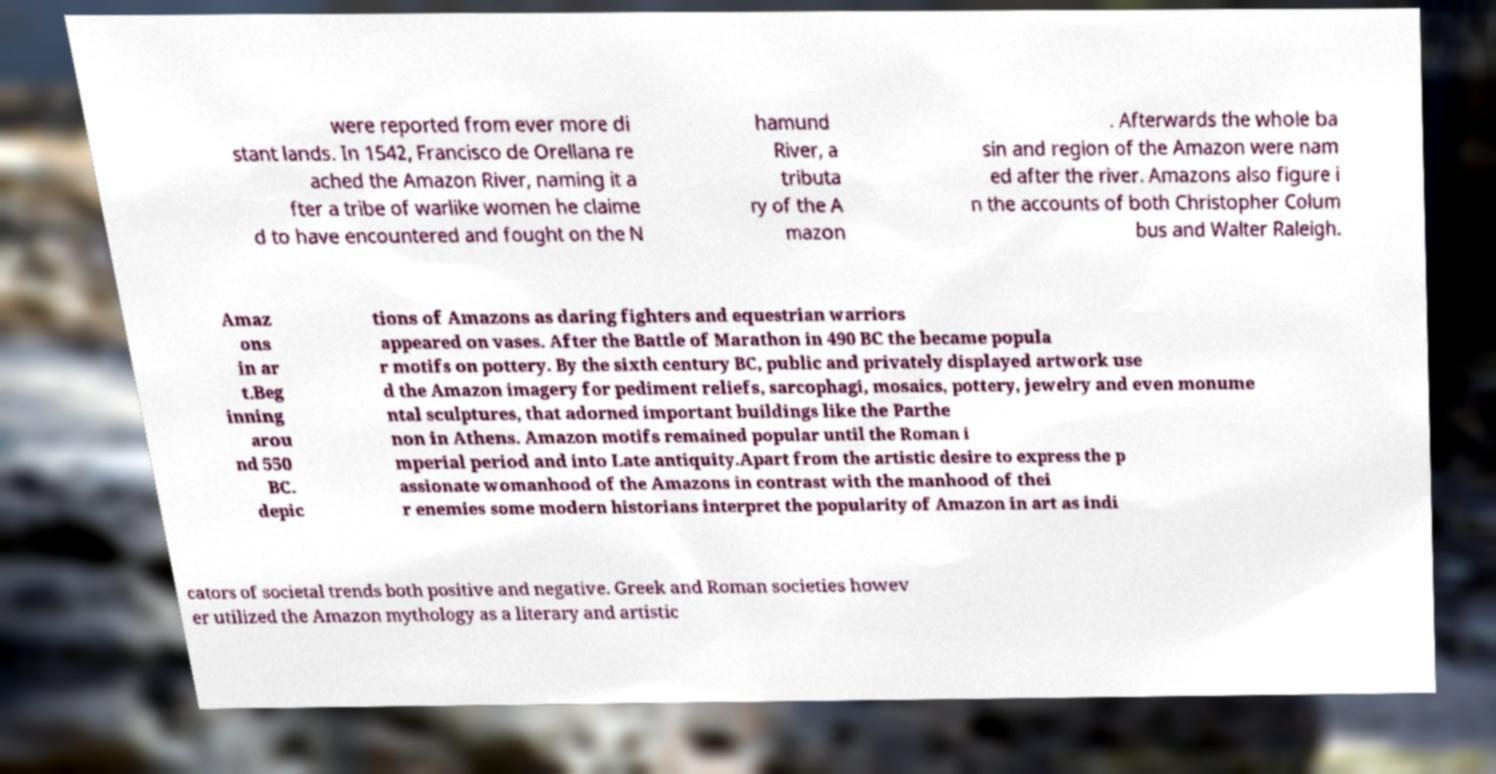There's text embedded in this image that I need extracted. Can you transcribe it verbatim? were reported from ever more di stant lands. In 1542, Francisco de Orellana re ached the Amazon River, naming it a fter a tribe of warlike women he claime d to have encountered and fought on the N hamund River, a tributa ry of the A mazon . Afterwards the whole ba sin and region of the Amazon were nam ed after the river. Amazons also figure i n the accounts of both Christopher Colum bus and Walter Raleigh. Amaz ons in ar t.Beg inning arou nd 550 BC. depic tions of Amazons as daring fighters and equestrian warriors appeared on vases. After the Battle of Marathon in 490 BC the became popula r motifs on pottery. By the sixth century BC, public and privately displayed artwork use d the Amazon imagery for pediment reliefs, sarcophagi, mosaics, pottery, jewelry and even monume ntal sculptures, that adorned important buildings like the Parthe non in Athens. Amazon motifs remained popular until the Roman i mperial period and into Late antiquity.Apart from the artistic desire to express the p assionate womanhood of the Amazons in contrast with the manhood of thei r enemies some modern historians interpret the popularity of Amazon in art as indi cators of societal trends both positive and negative. Greek and Roman societies howev er utilized the Amazon mythology as a literary and artistic 